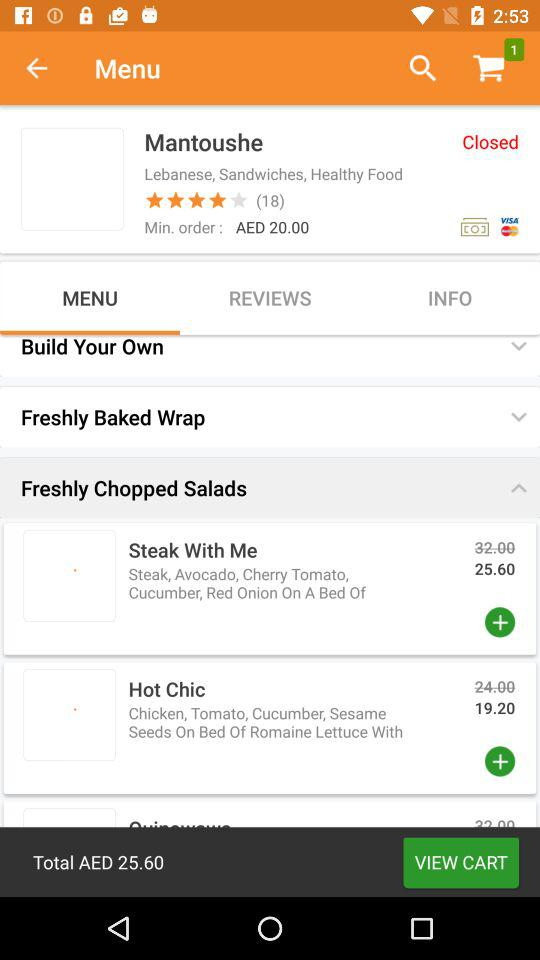How many reviews are there? There are 18 reviews. 